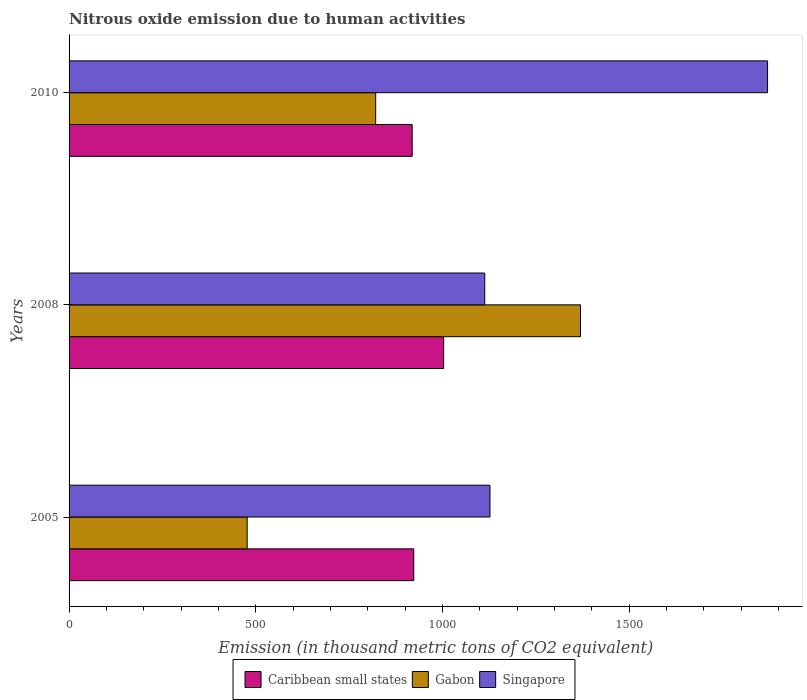How many groups of bars are there?
Offer a terse response. 3. Are the number of bars per tick equal to the number of legend labels?
Your response must be concise. Yes. Are the number of bars on each tick of the Y-axis equal?
Keep it short and to the point. Yes. How many bars are there on the 1st tick from the top?
Provide a succinct answer. 3. How many bars are there on the 1st tick from the bottom?
Ensure brevity in your answer.  3. What is the amount of nitrous oxide emitted in Caribbean small states in 2005?
Keep it short and to the point. 923.3. Across all years, what is the maximum amount of nitrous oxide emitted in Caribbean small states?
Keep it short and to the point. 1003.4. Across all years, what is the minimum amount of nitrous oxide emitted in Caribbean small states?
Make the answer very short. 919.1. In which year was the amount of nitrous oxide emitted in Gabon maximum?
Provide a succinct answer. 2008. What is the total amount of nitrous oxide emitted in Caribbean small states in the graph?
Offer a very short reply. 2845.8. What is the difference between the amount of nitrous oxide emitted in Gabon in 2005 and that in 2008?
Your answer should be compact. -892.9. What is the difference between the amount of nitrous oxide emitted in Singapore in 2010 and the amount of nitrous oxide emitted in Caribbean small states in 2008?
Your answer should be compact. 867.7. What is the average amount of nitrous oxide emitted in Gabon per year?
Provide a short and direct response. 889.47. In the year 2005, what is the difference between the amount of nitrous oxide emitted in Caribbean small states and amount of nitrous oxide emitted in Singapore?
Provide a succinct answer. -204.2. In how many years, is the amount of nitrous oxide emitted in Gabon greater than 1000 thousand metric tons?
Give a very brief answer. 1. What is the ratio of the amount of nitrous oxide emitted in Gabon in 2005 to that in 2008?
Your answer should be very brief. 0.35. Is the difference between the amount of nitrous oxide emitted in Caribbean small states in 2005 and 2010 greater than the difference between the amount of nitrous oxide emitted in Singapore in 2005 and 2010?
Provide a succinct answer. Yes. What is the difference between the highest and the second highest amount of nitrous oxide emitted in Singapore?
Provide a short and direct response. 743.6. What is the difference between the highest and the lowest amount of nitrous oxide emitted in Singapore?
Provide a succinct answer. 757.6. In how many years, is the amount of nitrous oxide emitted in Gabon greater than the average amount of nitrous oxide emitted in Gabon taken over all years?
Your answer should be compact. 1. What does the 3rd bar from the top in 2008 represents?
Offer a terse response. Caribbean small states. What does the 1st bar from the bottom in 2008 represents?
Offer a very short reply. Caribbean small states. Is it the case that in every year, the sum of the amount of nitrous oxide emitted in Singapore and amount of nitrous oxide emitted in Gabon is greater than the amount of nitrous oxide emitted in Caribbean small states?
Your response must be concise. Yes. How many bars are there?
Make the answer very short. 9. Are all the bars in the graph horizontal?
Provide a short and direct response. Yes. What is the difference between two consecutive major ticks on the X-axis?
Offer a terse response. 500. Are the values on the major ticks of X-axis written in scientific E-notation?
Provide a short and direct response. No. Does the graph contain any zero values?
Make the answer very short. No. Where does the legend appear in the graph?
Ensure brevity in your answer.  Bottom center. How many legend labels are there?
Your answer should be compact. 3. How are the legend labels stacked?
Provide a short and direct response. Horizontal. What is the title of the graph?
Your response must be concise. Nitrous oxide emission due to human activities. What is the label or title of the X-axis?
Your answer should be compact. Emission (in thousand metric tons of CO2 equivalent). What is the label or title of the Y-axis?
Your response must be concise. Years. What is the Emission (in thousand metric tons of CO2 equivalent) in Caribbean small states in 2005?
Ensure brevity in your answer.  923.3. What is the Emission (in thousand metric tons of CO2 equivalent) of Gabon in 2005?
Make the answer very short. 477.1. What is the Emission (in thousand metric tons of CO2 equivalent) of Singapore in 2005?
Provide a succinct answer. 1127.5. What is the Emission (in thousand metric tons of CO2 equivalent) in Caribbean small states in 2008?
Ensure brevity in your answer.  1003.4. What is the Emission (in thousand metric tons of CO2 equivalent) of Gabon in 2008?
Offer a terse response. 1370. What is the Emission (in thousand metric tons of CO2 equivalent) of Singapore in 2008?
Your answer should be very brief. 1113.5. What is the Emission (in thousand metric tons of CO2 equivalent) in Caribbean small states in 2010?
Give a very brief answer. 919.1. What is the Emission (in thousand metric tons of CO2 equivalent) in Gabon in 2010?
Your answer should be compact. 821.3. What is the Emission (in thousand metric tons of CO2 equivalent) of Singapore in 2010?
Offer a very short reply. 1871.1. Across all years, what is the maximum Emission (in thousand metric tons of CO2 equivalent) of Caribbean small states?
Your answer should be compact. 1003.4. Across all years, what is the maximum Emission (in thousand metric tons of CO2 equivalent) in Gabon?
Ensure brevity in your answer.  1370. Across all years, what is the maximum Emission (in thousand metric tons of CO2 equivalent) of Singapore?
Provide a succinct answer. 1871.1. Across all years, what is the minimum Emission (in thousand metric tons of CO2 equivalent) of Caribbean small states?
Give a very brief answer. 919.1. Across all years, what is the minimum Emission (in thousand metric tons of CO2 equivalent) in Gabon?
Your response must be concise. 477.1. Across all years, what is the minimum Emission (in thousand metric tons of CO2 equivalent) in Singapore?
Your answer should be compact. 1113.5. What is the total Emission (in thousand metric tons of CO2 equivalent) of Caribbean small states in the graph?
Ensure brevity in your answer.  2845.8. What is the total Emission (in thousand metric tons of CO2 equivalent) in Gabon in the graph?
Your answer should be very brief. 2668.4. What is the total Emission (in thousand metric tons of CO2 equivalent) in Singapore in the graph?
Provide a short and direct response. 4112.1. What is the difference between the Emission (in thousand metric tons of CO2 equivalent) in Caribbean small states in 2005 and that in 2008?
Keep it short and to the point. -80.1. What is the difference between the Emission (in thousand metric tons of CO2 equivalent) in Gabon in 2005 and that in 2008?
Offer a very short reply. -892.9. What is the difference between the Emission (in thousand metric tons of CO2 equivalent) in Caribbean small states in 2005 and that in 2010?
Your response must be concise. 4.2. What is the difference between the Emission (in thousand metric tons of CO2 equivalent) in Gabon in 2005 and that in 2010?
Your answer should be very brief. -344.2. What is the difference between the Emission (in thousand metric tons of CO2 equivalent) of Singapore in 2005 and that in 2010?
Offer a very short reply. -743.6. What is the difference between the Emission (in thousand metric tons of CO2 equivalent) of Caribbean small states in 2008 and that in 2010?
Ensure brevity in your answer.  84.3. What is the difference between the Emission (in thousand metric tons of CO2 equivalent) in Gabon in 2008 and that in 2010?
Give a very brief answer. 548.7. What is the difference between the Emission (in thousand metric tons of CO2 equivalent) in Singapore in 2008 and that in 2010?
Keep it short and to the point. -757.6. What is the difference between the Emission (in thousand metric tons of CO2 equivalent) of Caribbean small states in 2005 and the Emission (in thousand metric tons of CO2 equivalent) of Gabon in 2008?
Provide a short and direct response. -446.7. What is the difference between the Emission (in thousand metric tons of CO2 equivalent) in Caribbean small states in 2005 and the Emission (in thousand metric tons of CO2 equivalent) in Singapore in 2008?
Ensure brevity in your answer.  -190.2. What is the difference between the Emission (in thousand metric tons of CO2 equivalent) of Gabon in 2005 and the Emission (in thousand metric tons of CO2 equivalent) of Singapore in 2008?
Offer a very short reply. -636.4. What is the difference between the Emission (in thousand metric tons of CO2 equivalent) in Caribbean small states in 2005 and the Emission (in thousand metric tons of CO2 equivalent) in Gabon in 2010?
Give a very brief answer. 102. What is the difference between the Emission (in thousand metric tons of CO2 equivalent) in Caribbean small states in 2005 and the Emission (in thousand metric tons of CO2 equivalent) in Singapore in 2010?
Provide a succinct answer. -947.8. What is the difference between the Emission (in thousand metric tons of CO2 equivalent) in Gabon in 2005 and the Emission (in thousand metric tons of CO2 equivalent) in Singapore in 2010?
Ensure brevity in your answer.  -1394. What is the difference between the Emission (in thousand metric tons of CO2 equivalent) in Caribbean small states in 2008 and the Emission (in thousand metric tons of CO2 equivalent) in Gabon in 2010?
Give a very brief answer. 182.1. What is the difference between the Emission (in thousand metric tons of CO2 equivalent) in Caribbean small states in 2008 and the Emission (in thousand metric tons of CO2 equivalent) in Singapore in 2010?
Your answer should be compact. -867.7. What is the difference between the Emission (in thousand metric tons of CO2 equivalent) in Gabon in 2008 and the Emission (in thousand metric tons of CO2 equivalent) in Singapore in 2010?
Your response must be concise. -501.1. What is the average Emission (in thousand metric tons of CO2 equivalent) in Caribbean small states per year?
Keep it short and to the point. 948.6. What is the average Emission (in thousand metric tons of CO2 equivalent) of Gabon per year?
Your answer should be very brief. 889.47. What is the average Emission (in thousand metric tons of CO2 equivalent) in Singapore per year?
Offer a very short reply. 1370.7. In the year 2005, what is the difference between the Emission (in thousand metric tons of CO2 equivalent) in Caribbean small states and Emission (in thousand metric tons of CO2 equivalent) in Gabon?
Keep it short and to the point. 446.2. In the year 2005, what is the difference between the Emission (in thousand metric tons of CO2 equivalent) of Caribbean small states and Emission (in thousand metric tons of CO2 equivalent) of Singapore?
Offer a very short reply. -204.2. In the year 2005, what is the difference between the Emission (in thousand metric tons of CO2 equivalent) in Gabon and Emission (in thousand metric tons of CO2 equivalent) in Singapore?
Provide a succinct answer. -650.4. In the year 2008, what is the difference between the Emission (in thousand metric tons of CO2 equivalent) in Caribbean small states and Emission (in thousand metric tons of CO2 equivalent) in Gabon?
Offer a very short reply. -366.6. In the year 2008, what is the difference between the Emission (in thousand metric tons of CO2 equivalent) of Caribbean small states and Emission (in thousand metric tons of CO2 equivalent) of Singapore?
Offer a very short reply. -110.1. In the year 2008, what is the difference between the Emission (in thousand metric tons of CO2 equivalent) of Gabon and Emission (in thousand metric tons of CO2 equivalent) of Singapore?
Offer a very short reply. 256.5. In the year 2010, what is the difference between the Emission (in thousand metric tons of CO2 equivalent) of Caribbean small states and Emission (in thousand metric tons of CO2 equivalent) of Gabon?
Your response must be concise. 97.8. In the year 2010, what is the difference between the Emission (in thousand metric tons of CO2 equivalent) of Caribbean small states and Emission (in thousand metric tons of CO2 equivalent) of Singapore?
Offer a very short reply. -952. In the year 2010, what is the difference between the Emission (in thousand metric tons of CO2 equivalent) of Gabon and Emission (in thousand metric tons of CO2 equivalent) of Singapore?
Your response must be concise. -1049.8. What is the ratio of the Emission (in thousand metric tons of CO2 equivalent) of Caribbean small states in 2005 to that in 2008?
Your response must be concise. 0.92. What is the ratio of the Emission (in thousand metric tons of CO2 equivalent) in Gabon in 2005 to that in 2008?
Provide a short and direct response. 0.35. What is the ratio of the Emission (in thousand metric tons of CO2 equivalent) in Singapore in 2005 to that in 2008?
Your answer should be very brief. 1.01. What is the ratio of the Emission (in thousand metric tons of CO2 equivalent) of Gabon in 2005 to that in 2010?
Provide a succinct answer. 0.58. What is the ratio of the Emission (in thousand metric tons of CO2 equivalent) of Singapore in 2005 to that in 2010?
Ensure brevity in your answer.  0.6. What is the ratio of the Emission (in thousand metric tons of CO2 equivalent) of Caribbean small states in 2008 to that in 2010?
Offer a terse response. 1.09. What is the ratio of the Emission (in thousand metric tons of CO2 equivalent) in Gabon in 2008 to that in 2010?
Keep it short and to the point. 1.67. What is the ratio of the Emission (in thousand metric tons of CO2 equivalent) in Singapore in 2008 to that in 2010?
Ensure brevity in your answer.  0.6. What is the difference between the highest and the second highest Emission (in thousand metric tons of CO2 equivalent) of Caribbean small states?
Offer a very short reply. 80.1. What is the difference between the highest and the second highest Emission (in thousand metric tons of CO2 equivalent) in Gabon?
Offer a very short reply. 548.7. What is the difference between the highest and the second highest Emission (in thousand metric tons of CO2 equivalent) in Singapore?
Provide a succinct answer. 743.6. What is the difference between the highest and the lowest Emission (in thousand metric tons of CO2 equivalent) in Caribbean small states?
Provide a short and direct response. 84.3. What is the difference between the highest and the lowest Emission (in thousand metric tons of CO2 equivalent) in Gabon?
Offer a terse response. 892.9. What is the difference between the highest and the lowest Emission (in thousand metric tons of CO2 equivalent) in Singapore?
Keep it short and to the point. 757.6. 